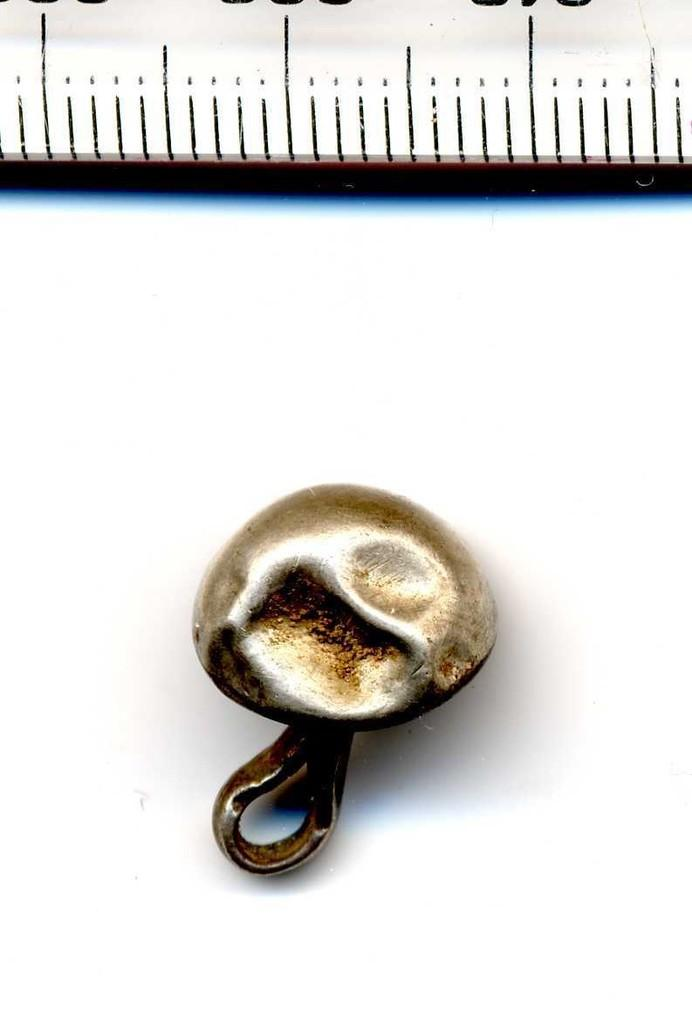What is the main subject in the center of the image? There is an object in the center of the image. What can be seen at the top of the image? There is a scale visible at the top of the image. What type of statement can be seen written on the pipe in the image? There is no pipe present in the image, so it is not possible to determine if there is a statement written on it. 